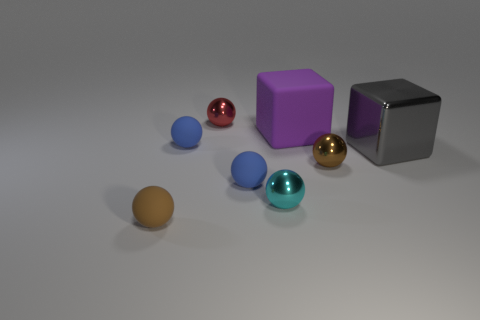Does the tiny brown shiny thing have the same shape as the big gray metal thing?
Keep it short and to the point. No. There is a blue rubber sphere that is in front of the brown ball that is on the right side of the brown matte object; what is its size?
Offer a very short reply. Small. There is another big thing that is the same shape as the large purple matte object; what is its color?
Your answer should be very brief. Gray. How big is the rubber cube?
Make the answer very short. Large. Is the size of the cyan metallic object the same as the purple cube?
Provide a succinct answer. No. What is the color of the shiny thing that is in front of the shiny block and to the right of the big matte object?
Your response must be concise. Brown. How many red spheres have the same material as the cyan sphere?
Provide a short and direct response. 1. How many tiny gray matte objects are there?
Provide a succinct answer. 0. Does the purple matte block have the same size as the gray shiny object on the right side of the red object?
Offer a very short reply. Yes. What material is the brown ball behind the tiny brown object that is on the left side of the tiny brown metal thing made of?
Provide a short and direct response. Metal. 